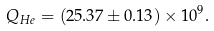Convert formula to latex. <formula><loc_0><loc_0><loc_500><loc_500>Q _ { H e } = ( 2 5 . 3 7 \pm 0 . 1 3 ) \times 1 0 ^ { 9 } .</formula> 